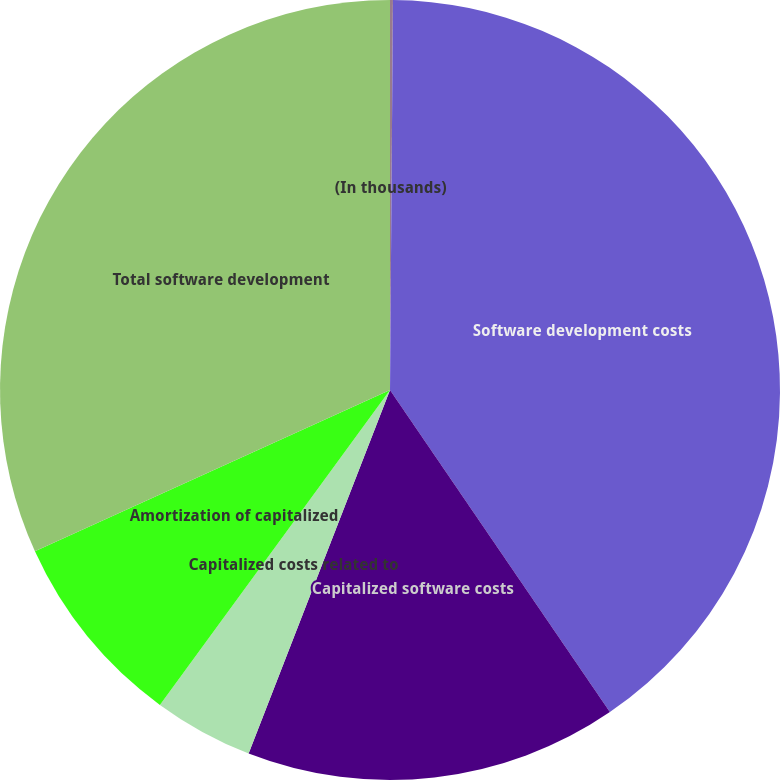Convert chart to OTSL. <chart><loc_0><loc_0><loc_500><loc_500><pie_chart><fcel>(In thousands)<fcel>Software development costs<fcel>Capitalized software costs<fcel>Capitalized costs related to<fcel>Amortization of capitalized<fcel>Total software development<nl><fcel>0.12%<fcel>40.35%<fcel>15.44%<fcel>4.14%<fcel>8.17%<fcel>31.79%<nl></chart> 